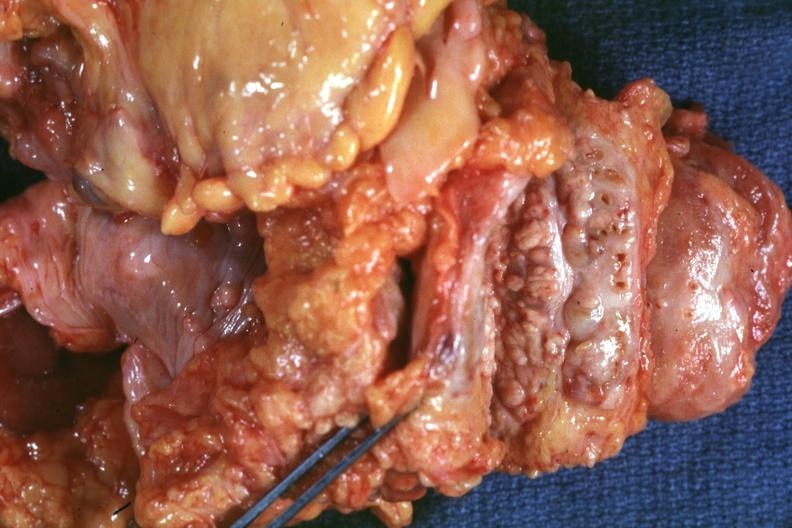s nodular parenchyma and dense intervening tumor tissue very good?
Answer the question using a single word or phrase. Yes 